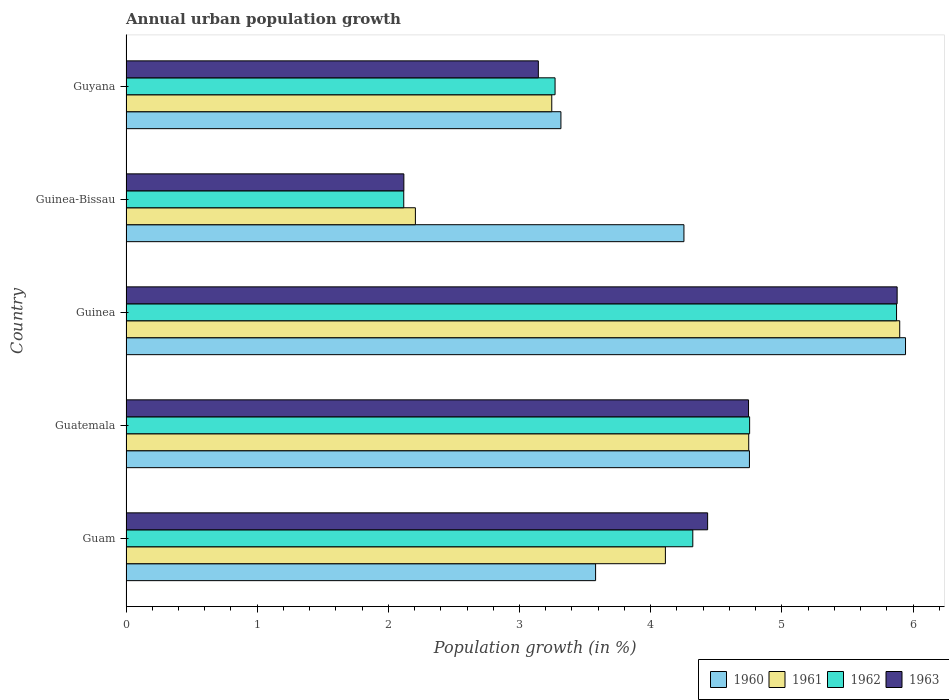How many different coloured bars are there?
Ensure brevity in your answer.  4. How many groups of bars are there?
Provide a succinct answer. 5. How many bars are there on the 1st tick from the top?
Your answer should be very brief. 4. What is the label of the 2nd group of bars from the top?
Keep it short and to the point. Guinea-Bissau. What is the percentage of urban population growth in 1962 in Guinea?
Provide a succinct answer. 5.87. Across all countries, what is the maximum percentage of urban population growth in 1960?
Offer a very short reply. 5.94. Across all countries, what is the minimum percentage of urban population growth in 1960?
Provide a succinct answer. 3.32. In which country was the percentage of urban population growth in 1962 maximum?
Your response must be concise. Guinea. In which country was the percentage of urban population growth in 1961 minimum?
Your answer should be very brief. Guinea-Bissau. What is the total percentage of urban population growth in 1962 in the graph?
Provide a succinct answer. 20.34. What is the difference between the percentage of urban population growth in 1963 in Guam and that in Guyana?
Your response must be concise. 1.29. What is the difference between the percentage of urban population growth in 1963 in Guinea and the percentage of urban population growth in 1961 in Guatemala?
Offer a terse response. 1.13. What is the average percentage of urban population growth in 1963 per country?
Provide a short and direct response. 4.06. What is the difference between the percentage of urban population growth in 1960 and percentage of urban population growth in 1961 in Guam?
Make the answer very short. -0.53. In how many countries, is the percentage of urban population growth in 1963 greater than 0.2 %?
Give a very brief answer. 5. What is the ratio of the percentage of urban population growth in 1962 in Guinea to that in Guyana?
Offer a terse response. 1.8. Is the percentage of urban population growth in 1961 in Guam less than that in Guatemala?
Offer a terse response. Yes. Is the difference between the percentage of urban population growth in 1960 in Guam and Guinea greater than the difference between the percentage of urban population growth in 1961 in Guam and Guinea?
Keep it short and to the point. No. What is the difference between the highest and the second highest percentage of urban population growth in 1960?
Keep it short and to the point. 1.19. What is the difference between the highest and the lowest percentage of urban population growth in 1961?
Your answer should be very brief. 3.69. In how many countries, is the percentage of urban population growth in 1960 greater than the average percentage of urban population growth in 1960 taken over all countries?
Your answer should be compact. 2. What does the 2nd bar from the top in Guinea represents?
Provide a succinct answer. 1962. Is it the case that in every country, the sum of the percentage of urban population growth in 1962 and percentage of urban population growth in 1961 is greater than the percentage of urban population growth in 1963?
Offer a terse response. Yes. How many bars are there?
Provide a succinct answer. 20. What is the difference between two consecutive major ticks on the X-axis?
Your response must be concise. 1. Are the values on the major ticks of X-axis written in scientific E-notation?
Your answer should be compact. No. Does the graph contain grids?
Give a very brief answer. No. Where does the legend appear in the graph?
Your response must be concise. Bottom right. How many legend labels are there?
Keep it short and to the point. 4. How are the legend labels stacked?
Give a very brief answer. Horizontal. What is the title of the graph?
Make the answer very short. Annual urban population growth. What is the label or title of the X-axis?
Keep it short and to the point. Population growth (in %). What is the label or title of the Y-axis?
Keep it short and to the point. Country. What is the Population growth (in %) in 1960 in Guam?
Your answer should be very brief. 3.58. What is the Population growth (in %) of 1961 in Guam?
Make the answer very short. 4.11. What is the Population growth (in %) in 1962 in Guam?
Offer a very short reply. 4.32. What is the Population growth (in %) in 1963 in Guam?
Provide a succinct answer. 4.43. What is the Population growth (in %) of 1960 in Guatemala?
Offer a terse response. 4.75. What is the Population growth (in %) of 1961 in Guatemala?
Ensure brevity in your answer.  4.75. What is the Population growth (in %) in 1962 in Guatemala?
Your response must be concise. 4.75. What is the Population growth (in %) in 1963 in Guatemala?
Provide a short and direct response. 4.75. What is the Population growth (in %) of 1960 in Guinea?
Provide a short and direct response. 5.94. What is the Population growth (in %) in 1961 in Guinea?
Your answer should be very brief. 5.9. What is the Population growth (in %) in 1962 in Guinea?
Keep it short and to the point. 5.87. What is the Population growth (in %) in 1963 in Guinea?
Give a very brief answer. 5.88. What is the Population growth (in %) of 1960 in Guinea-Bissau?
Your response must be concise. 4.25. What is the Population growth (in %) of 1961 in Guinea-Bissau?
Offer a very short reply. 2.21. What is the Population growth (in %) in 1962 in Guinea-Bissau?
Give a very brief answer. 2.12. What is the Population growth (in %) of 1963 in Guinea-Bissau?
Provide a short and direct response. 2.12. What is the Population growth (in %) of 1960 in Guyana?
Your response must be concise. 3.32. What is the Population growth (in %) of 1961 in Guyana?
Offer a very short reply. 3.25. What is the Population growth (in %) of 1962 in Guyana?
Ensure brevity in your answer.  3.27. What is the Population growth (in %) of 1963 in Guyana?
Offer a terse response. 3.14. Across all countries, what is the maximum Population growth (in %) of 1960?
Provide a succinct answer. 5.94. Across all countries, what is the maximum Population growth (in %) in 1961?
Make the answer very short. 5.9. Across all countries, what is the maximum Population growth (in %) in 1962?
Keep it short and to the point. 5.87. Across all countries, what is the maximum Population growth (in %) of 1963?
Make the answer very short. 5.88. Across all countries, what is the minimum Population growth (in %) in 1960?
Your answer should be very brief. 3.32. Across all countries, what is the minimum Population growth (in %) of 1961?
Provide a succinct answer. 2.21. Across all countries, what is the minimum Population growth (in %) of 1962?
Keep it short and to the point. 2.12. Across all countries, what is the minimum Population growth (in %) of 1963?
Your answer should be compact. 2.12. What is the total Population growth (in %) of 1960 in the graph?
Give a very brief answer. 21.85. What is the total Population growth (in %) in 1961 in the graph?
Offer a terse response. 20.21. What is the total Population growth (in %) of 1962 in the graph?
Offer a very short reply. 20.34. What is the total Population growth (in %) of 1963 in the graph?
Your answer should be very brief. 20.32. What is the difference between the Population growth (in %) in 1960 in Guam and that in Guatemala?
Give a very brief answer. -1.17. What is the difference between the Population growth (in %) in 1961 in Guam and that in Guatemala?
Provide a succinct answer. -0.64. What is the difference between the Population growth (in %) of 1962 in Guam and that in Guatemala?
Ensure brevity in your answer.  -0.43. What is the difference between the Population growth (in %) in 1963 in Guam and that in Guatemala?
Your response must be concise. -0.31. What is the difference between the Population growth (in %) in 1960 in Guam and that in Guinea?
Provide a short and direct response. -2.36. What is the difference between the Population growth (in %) in 1961 in Guam and that in Guinea?
Offer a very short reply. -1.79. What is the difference between the Population growth (in %) in 1962 in Guam and that in Guinea?
Give a very brief answer. -1.55. What is the difference between the Population growth (in %) of 1963 in Guam and that in Guinea?
Offer a terse response. -1.44. What is the difference between the Population growth (in %) of 1960 in Guam and that in Guinea-Bissau?
Offer a very short reply. -0.67. What is the difference between the Population growth (in %) of 1961 in Guam and that in Guinea-Bissau?
Offer a very short reply. 1.91. What is the difference between the Population growth (in %) of 1962 in Guam and that in Guinea-Bissau?
Offer a very short reply. 2.2. What is the difference between the Population growth (in %) in 1963 in Guam and that in Guinea-Bissau?
Offer a terse response. 2.32. What is the difference between the Population growth (in %) in 1960 in Guam and that in Guyana?
Make the answer very short. 0.26. What is the difference between the Population growth (in %) of 1961 in Guam and that in Guyana?
Your response must be concise. 0.87. What is the difference between the Population growth (in %) of 1962 in Guam and that in Guyana?
Make the answer very short. 1.05. What is the difference between the Population growth (in %) of 1963 in Guam and that in Guyana?
Provide a short and direct response. 1.29. What is the difference between the Population growth (in %) in 1960 in Guatemala and that in Guinea?
Provide a succinct answer. -1.19. What is the difference between the Population growth (in %) of 1961 in Guatemala and that in Guinea?
Provide a short and direct response. -1.15. What is the difference between the Population growth (in %) in 1962 in Guatemala and that in Guinea?
Ensure brevity in your answer.  -1.12. What is the difference between the Population growth (in %) in 1963 in Guatemala and that in Guinea?
Offer a very short reply. -1.13. What is the difference between the Population growth (in %) in 1960 in Guatemala and that in Guinea-Bissau?
Your answer should be compact. 0.5. What is the difference between the Population growth (in %) in 1961 in Guatemala and that in Guinea-Bissau?
Your answer should be compact. 2.54. What is the difference between the Population growth (in %) of 1962 in Guatemala and that in Guinea-Bissau?
Keep it short and to the point. 2.64. What is the difference between the Population growth (in %) in 1963 in Guatemala and that in Guinea-Bissau?
Keep it short and to the point. 2.63. What is the difference between the Population growth (in %) of 1960 in Guatemala and that in Guyana?
Provide a short and direct response. 1.44. What is the difference between the Population growth (in %) in 1961 in Guatemala and that in Guyana?
Offer a very short reply. 1.5. What is the difference between the Population growth (in %) of 1962 in Guatemala and that in Guyana?
Your answer should be compact. 1.48. What is the difference between the Population growth (in %) in 1963 in Guatemala and that in Guyana?
Keep it short and to the point. 1.6. What is the difference between the Population growth (in %) in 1960 in Guinea and that in Guinea-Bissau?
Make the answer very short. 1.69. What is the difference between the Population growth (in %) in 1961 in Guinea and that in Guinea-Bissau?
Ensure brevity in your answer.  3.69. What is the difference between the Population growth (in %) of 1962 in Guinea and that in Guinea-Bissau?
Make the answer very short. 3.76. What is the difference between the Population growth (in %) in 1963 in Guinea and that in Guinea-Bissau?
Keep it short and to the point. 3.76. What is the difference between the Population growth (in %) of 1960 in Guinea and that in Guyana?
Your answer should be very brief. 2.63. What is the difference between the Population growth (in %) of 1961 in Guinea and that in Guyana?
Provide a short and direct response. 2.65. What is the difference between the Population growth (in %) in 1962 in Guinea and that in Guyana?
Provide a short and direct response. 2.6. What is the difference between the Population growth (in %) of 1963 in Guinea and that in Guyana?
Your answer should be compact. 2.74. What is the difference between the Population growth (in %) in 1960 in Guinea-Bissau and that in Guyana?
Offer a very short reply. 0.94. What is the difference between the Population growth (in %) of 1961 in Guinea-Bissau and that in Guyana?
Ensure brevity in your answer.  -1.04. What is the difference between the Population growth (in %) of 1962 in Guinea-Bissau and that in Guyana?
Your answer should be compact. -1.15. What is the difference between the Population growth (in %) in 1963 in Guinea-Bissau and that in Guyana?
Make the answer very short. -1.03. What is the difference between the Population growth (in %) in 1960 in Guam and the Population growth (in %) in 1961 in Guatemala?
Provide a succinct answer. -1.17. What is the difference between the Population growth (in %) of 1960 in Guam and the Population growth (in %) of 1962 in Guatemala?
Keep it short and to the point. -1.17. What is the difference between the Population growth (in %) in 1960 in Guam and the Population growth (in %) in 1963 in Guatemala?
Your response must be concise. -1.17. What is the difference between the Population growth (in %) of 1961 in Guam and the Population growth (in %) of 1962 in Guatemala?
Provide a short and direct response. -0.64. What is the difference between the Population growth (in %) in 1961 in Guam and the Population growth (in %) in 1963 in Guatemala?
Your response must be concise. -0.63. What is the difference between the Population growth (in %) in 1962 in Guam and the Population growth (in %) in 1963 in Guatemala?
Give a very brief answer. -0.42. What is the difference between the Population growth (in %) in 1960 in Guam and the Population growth (in %) in 1961 in Guinea?
Keep it short and to the point. -2.32. What is the difference between the Population growth (in %) in 1960 in Guam and the Population growth (in %) in 1962 in Guinea?
Your answer should be compact. -2.29. What is the difference between the Population growth (in %) in 1960 in Guam and the Population growth (in %) in 1963 in Guinea?
Provide a short and direct response. -2.3. What is the difference between the Population growth (in %) in 1961 in Guam and the Population growth (in %) in 1962 in Guinea?
Offer a very short reply. -1.76. What is the difference between the Population growth (in %) in 1961 in Guam and the Population growth (in %) in 1963 in Guinea?
Offer a very short reply. -1.77. What is the difference between the Population growth (in %) in 1962 in Guam and the Population growth (in %) in 1963 in Guinea?
Your answer should be very brief. -1.56. What is the difference between the Population growth (in %) of 1960 in Guam and the Population growth (in %) of 1961 in Guinea-Bissau?
Keep it short and to the point. 1.37. What is the difference between the Population growth (in %) in 1960 in Guam and the Population growth (in %) in 1962 in Guinea-Bissau?
Your answer should be very brief. 1.46. What is the difference between the Population growth (in %) of 1960 in Guam and the Population growth (in %) of 1963 in Guinea-Bissau?
Your response must be concise. 1.46. What is the difference between the Population growth (in %) of 1961 in Guam and the Population growth (in %) of 1962 in Guinea-Bissau?
Provide a short and direct response. 1.99. What is the difference between the Population growth (in %) in 1961 in Guam and the Population growth (in %) in 1963 in Guinea-Bissau?
Offer a terse response. 1.99. What is the difference between the Population growth (in %) of 1962 in Guam and the Population growth (in %) of 1963 in Guinea-Bissau?
Offer a terse response. 2.2. What is the difference between the Population growth (in %) of 1960 in Guam and the Population growth (in %) of 1961 in Guyana?
Keep it short and to the point. 0.33. What is the difference between the Population growth (in %) in 1960 in Guam and the Population growth (in %) in 1962 in Guyana?
Make the answer very short. 0.31. What is the difference between the Population growth (in %) of 1960 in Guam and the Population growth (in %) of 1963 in Guyana?
Offer a terse response. 0.44. What is the difference between the Population growth (in %) of 1961 in Guam and the Population growth (in %) of 1962 in Guyana?
Ensure brevity in your answer.  0.84. What is the difference between the Population growth (in %) in 1961 in Guam and the Population growth (in %) in 1963 in Guyana?
Your answer should be very brief. 0.97. What is the difference between the Population growth (in %) of 1962 in Guam and the Population growth (in %) of 1963 in Guyana?
Provide a short and direct response. 1.18. What is the difference between the Population growth (in %) of 1960 in Guatemala and the Population growth (in %) of 1961 in Guinea?
Keep it short and to the point. -1.15. What is the difference between the Population growth (in %) in 1960 in Guatemala and the Population growth (in %) in 1962 in Guinea?
Provide a succinct answer. -1.12. What is the difference between the Population growth (in %) in 1960 in Guatemala and the Population growth (in %) in 1963 in Guinea?
Provide a short and direct response. -1.13. What is the difference between the Population growth (in %) of 1961 in Guatemala and the Population growth (in %) of 1962 in Guinea?
Your response must be concise. -1.13. What is the difference between the Population growth (in %) in 1961 in Guatemala and the Population growth (in %) in 1963 in Guinea?
Offer a terse response. -1.13. What is the difference between the Population growth (in %) in 1962 in Guatemala and the Population growth (in %) in 1963 in Guinea?
Your answer should be compact. -1.12. What is the difference between the Population growth (in %) of 1960 in Guatemala and the Population growth (in %) of 1961 in Guinea-Bissau?
Your response must be concise. 2.55. What is the difference between the Population growth (in %) of 1960 in Guatemala and the Population growth (in %) of 1962 in Guinea-Bissau?
Provide a succinct answer. 2.64. What is the difference between the Population growth (in %) in 1960 in Guatemala and the Population growth (in %) in 1963 in Guinea-Bissau?
Your response must be concise. 2.63. What is the difference between the Population growth (in %) in 1961 in Guatemala and the Population growth (in %) in 1962 in Guinea-Bissau?
Offer a very short reply. 2.63. What is the difference between the Population growth (in %) in 1961 in Guatemala and the Population growth (in %) in 1963 in Guinea-Bissau?
Offer a terse response. 2.63. What is the difference between the Population growth (in %) in 1962 in Guatemala and the Population growth (in %) in 1963 in Guinea-Bissau?
Give a very brief answer. 2.64. What is the difference between the Population growth (in %) in 1960 in Guatemala and the Population growth (in %) in 1961 in Guyana?
Your answer should be very brief. 1.51. What is the difference between the Population growth (in %) of 1960 in Guatemala and the Population growth (in %) of 1962 in Guyana?
Give a very brief answer. 1.48. What is the difference between the Population growth (in %) in 1960 in Guatemala and the Population growth (in %) in 1963 in Guyana?
Offer a terse response. 1.61. What is the difference between the Population growth (in %) in 1961 in Guatemala and the Population growth (in %) in 1962 in Guyana?
Provide a short and direct response. 1.48. What is the difference between the Population growth (in %) of 1961 in Guatemala and the Population growth (in %) of 1963 in Guyana?
Ensure brevity in your answer.  1.6. What is the difference between the Population growth (in %) in 1962 in Guatemala and the Population growth (in %) in 1963 in Guyana?
Ensure brevity in your answer.  1.61. What is the difference between the Population growth (in %) of 1960 in Guinea and the Population growth (in %) of 1961 in Guinea-Bissau?
Give a very brief answer. 3.74. What is the difference between the Population growth (in %) of 1960 in Guinea and the Population growth (in %) of 1962 in Guinea-Bissau?
Provide a short and direct response. 3.83. What is the difference between the Population growth (in %) in 1960 in Guinea and the Population growth (in %) in 1963 in Guinea-Bissau?
Your answer should be very brief. 3.82. What is the difference between the Population growth (in %) of 1961 in Guinea and the Population growth (in %) of 1962 in Guinea-Bissau?
Your answer should be compact. 3.78. What is the difference between the Population growth (in %) of 1961 in Guinea and the Population growth (in %) of 1963 in Guinea-Bissau?
Offer a terse response. 3.78. What is the difference between the Population growth (in %) of 1962 in Guinea and the Population growth (in %) of 1963 in Guinea-Bissau?
Your answer should be very brief. 3.76. What is the difference between the Population growth (in %) in 1960 in Guinea and the Population growth (in %) in 1961 in Guyana?
Your answer should be very brief. 2.7. What is the difference between the Population growth (in %) in 1960 in Guinea and the Population growth (in %) in 1962 in Guyana?
Keep it short and to the point. 2.67. What is the difference between the Population growth (in %) of 1960 in Guinea and the Population growth (in %) of 1963 in Guyana?
Offer a very short reply. 2.8. What is the difference between the Population growth (in %) of 1961 in Guinea and the Population growth (in %) of 1962 in Guyana?
Offer a very short reply. 2.63. What is the difference between the Population growth (in %) in 1961 in Guinea and the Population growth (in %) in 1963 in Guyana?
Provide a short and direct response. 2.76. What is the difference between the Population growth (in %) of 1962 in Guinea and the Population growth (in %) of 1963 in Guyana?
Your answer should be compact. 2.73. What is the difference between the Population growth (in %) of 1960 in Guinea-Bissau and the Population growth (in %) of 1961 in Guyana?
Ensure brevity in your answer.  1.01. What is the difference between the Population growth (in %) in 1960 in Guinea-Bissau and the Population growth (in %) in 1962 in Guyana?
Provide a succinct answer. 0.98. What is the difference between the Population growth (in %) in 1960 in Guinea-Bissau and the Population growth (in %) in 1963 in Guyana?
Your response must be concise. 1.11. What is the difference between the Population growth (in %) of 1961 in Guinea-Bissau and the Population growth (in %) of 1962 in Guyana?
Keep it short and to the point. -1.06. What is the difference between the Population growth (in %) of 1961 in Guinea-Bissau and the Population growth (in %) of 1963 in Guyana?
Provide a short and direct response. -0.94. What is the difference between the Population growth (in %) of 1962 in Guinea-Bissau and the Population growth (in %) of 1963 in Guyana?
Your answer should be compact. -1.03. What is the average Population growth (in %) of 1960 per country?
Your answer should be very brief. 4.37. What is the average Population growth (in %) of 1961 per country?
Your answer should be compact. 4.04. What is the average Population growth (in %) in 1962 per country?
Your answer should be very brief. 4.07. What is the average Population growth (in %) of 1963 per country?
Provide a short and direct response. 4.06. What is the difference between the Population growth (in %) of 1960 and Population growth (in %) of 1961 in Guam?
Offer a very short reply. -0.53. What is the difference between the Population growth (in %) of 1960 and Population growth (in %) of 1962 in Guam?
Make the answer very short. -0.74. What is the difference between the Population growth (in %) in 1960 and Population growth (in %) in 1963 in Guam?
Your answer should be compact. -0.85. What is the difference between the Population growth (in %) in 1961 and Population growth (in %) in 1962 in Guam?
Your answer should be very brief. -0.21. What is the difference between the Population growth (in %) in 1961 and Population growth (in %) in 1963 in Guam?
Offer a very short reply. -0.32. What is the difference between the Population growth (in %) in 1962 and Population growth (in %) in 1963 in Guam?
Offer a terse response. -0.11. What is the difference between the Population growth (in %) in 1960 and Population growth (in %) in 1961 in Guatemala?
Your answer should be compact. 0.01. What is the difference between the Population growth (in %) of 1960 and Population growth (in %) of 1962 in Guatemala?
Make the answer very short. -0. What is the difference between the Population growth (in %) of 1960 and Population growth (in %) of 1963 in Guatemala?
Keep it short and to the point. 0.01. What is the difference between the Population growth (in %) in 1961 and Population growth (in %) in 1962 in Guatemala?
Give a very brief answer. -0.01. What is the difference between the Population growth (in %) in 1961 and Population growth (in %) in 1963 in Guatemala?
Make the answer very short. 0. What is the difference between the Population growth (in %) of 1962 and Population growth (in %) of 1963 in Guatemala?
Make the answer very short. 0.01. What is the difference between the Population growth (in %) of 1960 and Population growth (in %) of 1961 in Guinea?
Provide a succinct answer. 0.04. What is the difference between the Population growth (in %) of 1960 and Population growth (in %) of 1962 in Guinea?
Give a very brief answer. 0.07. What is the difference between the Population growth (in %) in 1960 and Population growth (in %) in 1963 in Guinea?
Give a very brief answer. 0.06. What is the difference between the Population growth (in %) in 1961 and Population growth (in %) in 1962 in Guinea?
Ensure brevity in your answer.  0.02. What is the difference between the Population growth (in %) of 1961 and Population growth (in %) of 1963 in Guinea?
Provide a short and direct response. 0.02. What is the difference between the Population growth (in %) in 1962 and Population growth (in %) in 1963 in Guinea?
Offer a terse response. -0. What is the difference between the Population growth (in %) in 1960 and Population growth (in %) in 1961 in Guinea-Bissau?
Offer a terse response. 2.05. What is the difference between the Population growth (in %) of 1960 and Population growth (in %) of 1962 in Guinea-Bissau?
Provide a succinct answer. 2.14. What is the difference between the Population growth (in %) in 1960 and Population growth (in %) in 1963 in Guinea-Bissau?
Provide a short and direct response. 2.14. What is the difference between the Population growth (in %) in 1961 and Population growth (in %) in 1962 in Guinea-Bissau?
Make the answer very short. 0.09. What is the difference between the Population growth (in %) in 1961 and Population growth (in %) in 1963 in Guinea-Bissau?
Provide a short and direct response. 0.09. What is the difference between the Population growth (in %) in 1962 and Population growth (in %) in 1963 in Guinea-Bissau?
Make the answer very short. -0. What is the difference between the Population growth (in %) of 1960 and Population growth (in %) of 1961 in Guyana?
Ensure brevity in your answer.  0.07. What is the difference between the Population growth (in %) of 1960 and Population growth (in %) of 1962 in Guyana?
Keep it short and to the point. 0.04. What is the difference between the Population growth (in %) in 1960 and Population growth (in %) in 1963 in Guyana?
Provide a succinct answer. 0.17. What is the difference between the Population growth (in %) in 1961 and Population growth (in %) in 1962 in Guyana?
Give a very brief answer. -0.03. What is the difference between the Population growth (in %) of 1961 and Population growth (in %) of 1963 in Guyana?
Provide a succinct answer. 0.1. What is the difference between the Population growth (in %) of 1962 and Population growth (in %) of 1963 in Guyana?
Provide a succinct answer. 0.13. What is the ratio of the Population growth (in %) of 1960 in Guam to that in Guatemala?
Your response must be concise. 0.75. What is the ratio of the Population growth (in %) in 1961 in Guam to that in Guatemala?
Give a very brief answer. 0.87. What is the ratio of the Population growth (in %) of 1962 in Guam to that in Guatemala?
Offer a terse response. 0.91. What is the ratio of the Population growth (in %) of 1963 in Guam to that in Guatemala?
Make the answer very short. 0.93. What is the ratio of the Population growth (in %) in 1960 in Guam to that in Guinea?
Give a very brief answer. 0.6. What is the ratio of the Population growth (in %) of 1961 in Guam to that in Guinea?
Make the answer very short. 0.7. What is the ratio of the Population growth (in %) of 1962 in Guam to that in Guinea?
Keep it short and to the point. 0.74. What is the ratio of the Population growth (in %) of 1963 in Guam to that in Guinea?
Your response must be concise. 0.75. What is the ratio of the Population growth (in %) in 1960 in Guam to that in Guinea-Bissau?
Provide a short and direct response. 0.84. What is the ratio of the Population growth (in %) of 1961 in Guam to that in Guinea-Bissau?
Offer a terse response. 1.86. What is the ratio of the Population growth (in %) in 1962 in Guam to that in Guinea-Bissau?
Offer a very short reply. 2.04. What is the ratio of the Population growth (in %) of 1963 in Guam to that in Guinea-Bissau?
Provide a short and direct response. 2.09. What is the ratio of the Population growth (in %) of 1960 in Guam to that in Guyana?
Offer a terse response. 1.08. What is the ratio of the Population growth (in %) in 1961 in Guam to that in Guyana?
Your response must be concise. 1.27. What is the ratio of the Population growth (in %) of 1962 in Guam to that in Guyana?
Provide a succinct answer. 1.32. What is the ratio of the Population growth (in %) in 1963 in Guam to that in Guyana?
Your response must be concise. 1.41. What is the ratio of the Population growth (in %) in 1960 in Guatemala to that in Guinea?
Give a very brief answer. 0.8. What is the ratio of the Population growth (in %) of 1961 in Guatemala to that in Guinea?
Give a very brief answer. 0.8. What is the ratio of the Population growth (in %) of 1962 in Guatemala to that in Guinea?
Keep it short and to the point. 0.81. What is the ratio of the Population growth (in %) of 1963 in Guatemala to that in Guinea?
Offer a very short reply. 0.81. What is the ratio of the Population growth (in %) in 1960 in Guatemala to that in Guinea-Bissau?
Make the answer very short. 1.12. What is the ratio of the Population growth (in %) in 1961 in Guatemala to that in Guinea-Bissau?
Keep it short and to the point. 2.15. What is the ratio of the Population growth (in %) in 1962 in Guatemala to that in Guinea-Bissau?
Your answer should be very brief. 2.25. What is the ratio of the Population growth (in %) of 1963 in Guatemala to that in Guinea-Bissau?
Give a very brief answer. 2.24. What is the ratio of the Population growth (in %) of 1960 in Guatemala to that in Guyana?
Ensure brevity in your answer.  1.43. What is the ratio of the Population growth (in %) in 1961 in Guatemala to that in Guyana?
Your answer should be compact. 1.46. What is the ratio of the Population growth (in %) in 1962 in Guatemala to that in Guyana?
Offer a very short reply. 1.45. What is the ratio of the Population growth (in %) of 1963 in Guatemala to that in Guyana?
Your answer should be very brief. 1.51. What is the ratio of the Population growth (in %) in 1960 in Guinea to that in Guinea-Bissau?
Provide a short and direct response. 1.4. What is the ratio of the Population growth (in %) in 1961 in Guinea to that in Guinea-Bissau?
Your answer should be compact. 2.67. What is the ratio of the Population growth (in %) in 1962 in Guinea to that in Guinea-Bissau?
Your answer should be very brief. 2.77. What is the ratio of the Population growth (in %) in 1963 in Guinea to that in Guinea-Bissau?
Make the answer very short. 2.78. What is the ratio of the Population growth (in %) in 1960 in Guinea to that in Guyana?
Your answer should be very brief. 1.79. What is the ratio of the Population growth (in %) of 1961 in Guinea to that in Guyana?
Your answer should be very brief. 1.82. What is the ratio of the Population growth (in %) of 1962 in Guinea to that in Guyana?
Make the answer very short. 1.8. What is the ratio of the Population growth (in %) of 1963 in Guinea to that in Guyana?
Provide a short and direct response. 1.87. What is the ratio of the Population growth (in %) in 1960 in Guinea-Bissau to that in Guyana?
Offer a very short reply. 1.28. What is the ratio of the Population growth (in %) of 1961 in Guinea-Bissau to that in Guyana?
Offer a terse response. 0.68. What is the ratio of the Population growth (in %) of 1962 in Guinea-Bissau to that in Guyana?
Offer a very short reply. 0.65. What is the ratio of the Population growth (in %) of 1963 in Guinea-Bissau to that in Guyana?
Your response must be concise. 0.67. What is the difference between the highest and the second highest Population growth (in %) of 1960?
Provide a succinct answer. 1.19. What is the difference between the highest and the second highest Population growth (in %) of 1961?
Give a very brief answer. 1.15. What is the difference between the highest and the second highest Population growth (in %) in 1962?
Your response must be concise. 1.12. What is the difference between the highest and the second highest Population growth (in %) of 1963?
Ensure brevity in your answer.  1.13. What is the difference between the highest and the lowest Population growth (in %) of 1960?
Provide a short and direct response. 2.63. What is the difference between the highest and the lowest Population growth (in %) of 1961?
Your answer should be very brief. 3.69. What is the difference between the highest and the lowest Population growth (in %) in 1962?
Offer a terse response. 3.76. What is the difference between the highest and the lowest Population growth (in %) of 1963?
Offer a terse response. 3.76. 